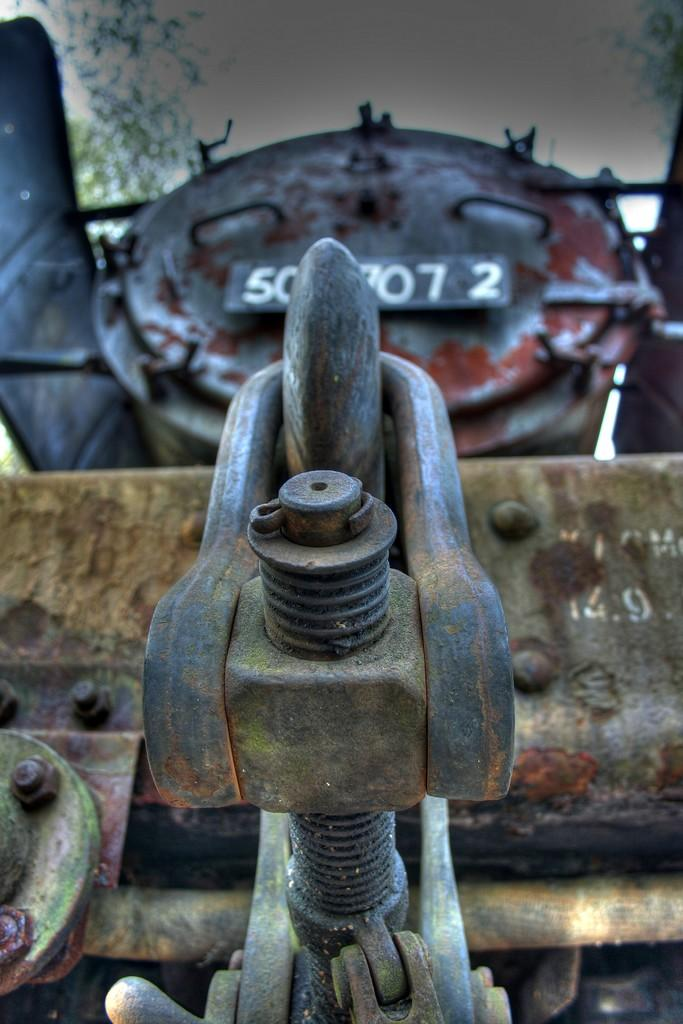What is the main subject of the image? The main subject of the image is a train. In which direction is the train facing? The train is facing forward. What can be seen on the front side of the train? There is a nut and bolt on the front side of the train. What is visible behind the train? There are trees behind the train. What is visible above the train? The sky is visible in the image. What type of wax is being used to polish the train in the image? There is no indication in the image that wax is being used to polish the train, and therefore no such activity can be observed. 